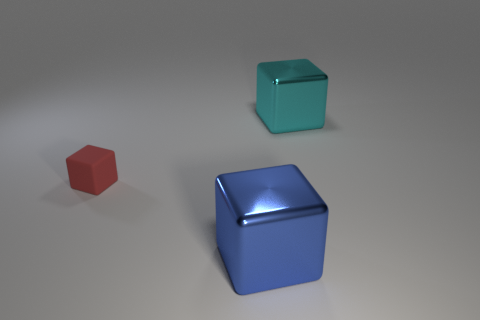Subtract all small cubes. How many cubes are left? 2 Subtract all blue cubes. How many cubes are left? 2 Add 3 red blocks. How many objects exist? 6 Subtract 1 cubes. How many cubes are left? 2 Add 1 big objects. How many big objects exist? 3 Subtract 0 yellow cylinders. How many objects are left? 3 Subtract all yellow blocks. Subtract all red cylinders. How many blocks are left? 3 Subtract all small rubber things. Subtract all small red metallic cylinders. How many objects are left? 2 Add 2 small matte things. How many small matte things are left? 3 